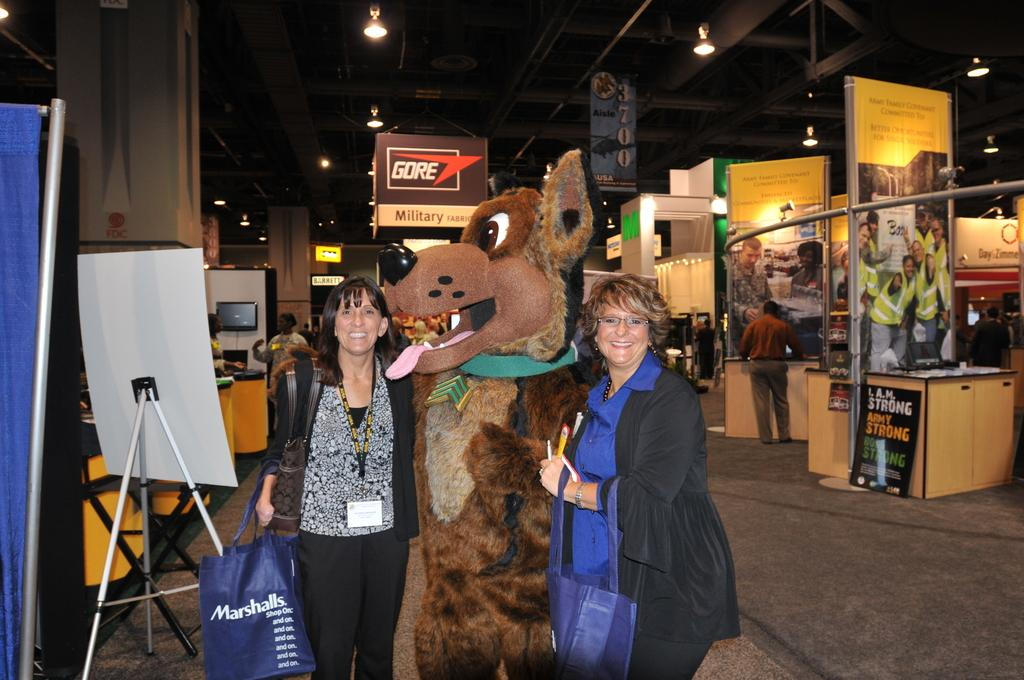How many women are in the image? There are two women in the image. What are the women holding? The women are holding handbags. What is located between the two women? There is a doll between the two women. What can be seen in the background of the image? There are counters, banners, and lights visible in the background of the image. What type of mint can be seen growing near the counters in the image? There is no mint visible in the image; it only features two women, a doll, and background elements such as counters, banners, and lights. 